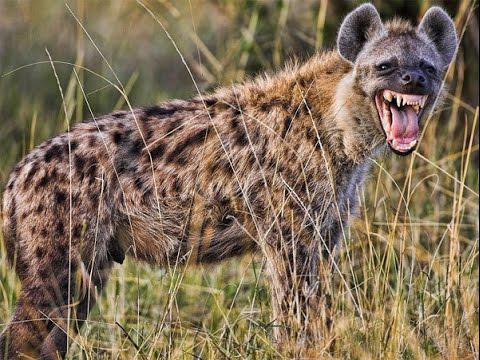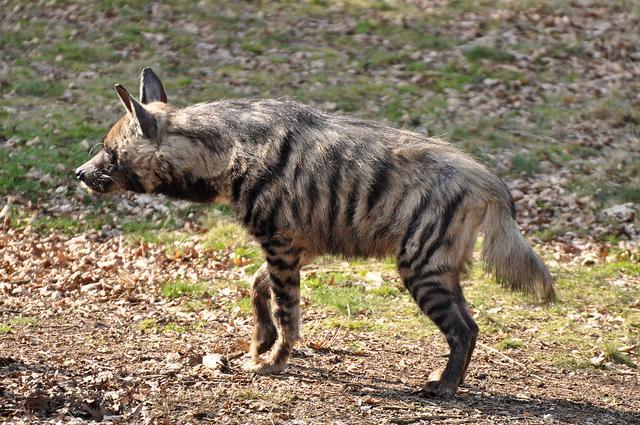The first image is the image on the left, the second image is the image on the right. Evaluate the accuracy of this statement regarding the images: "A hyena has its mouth wide open". Is it true? Answer yes or no. Yes. 